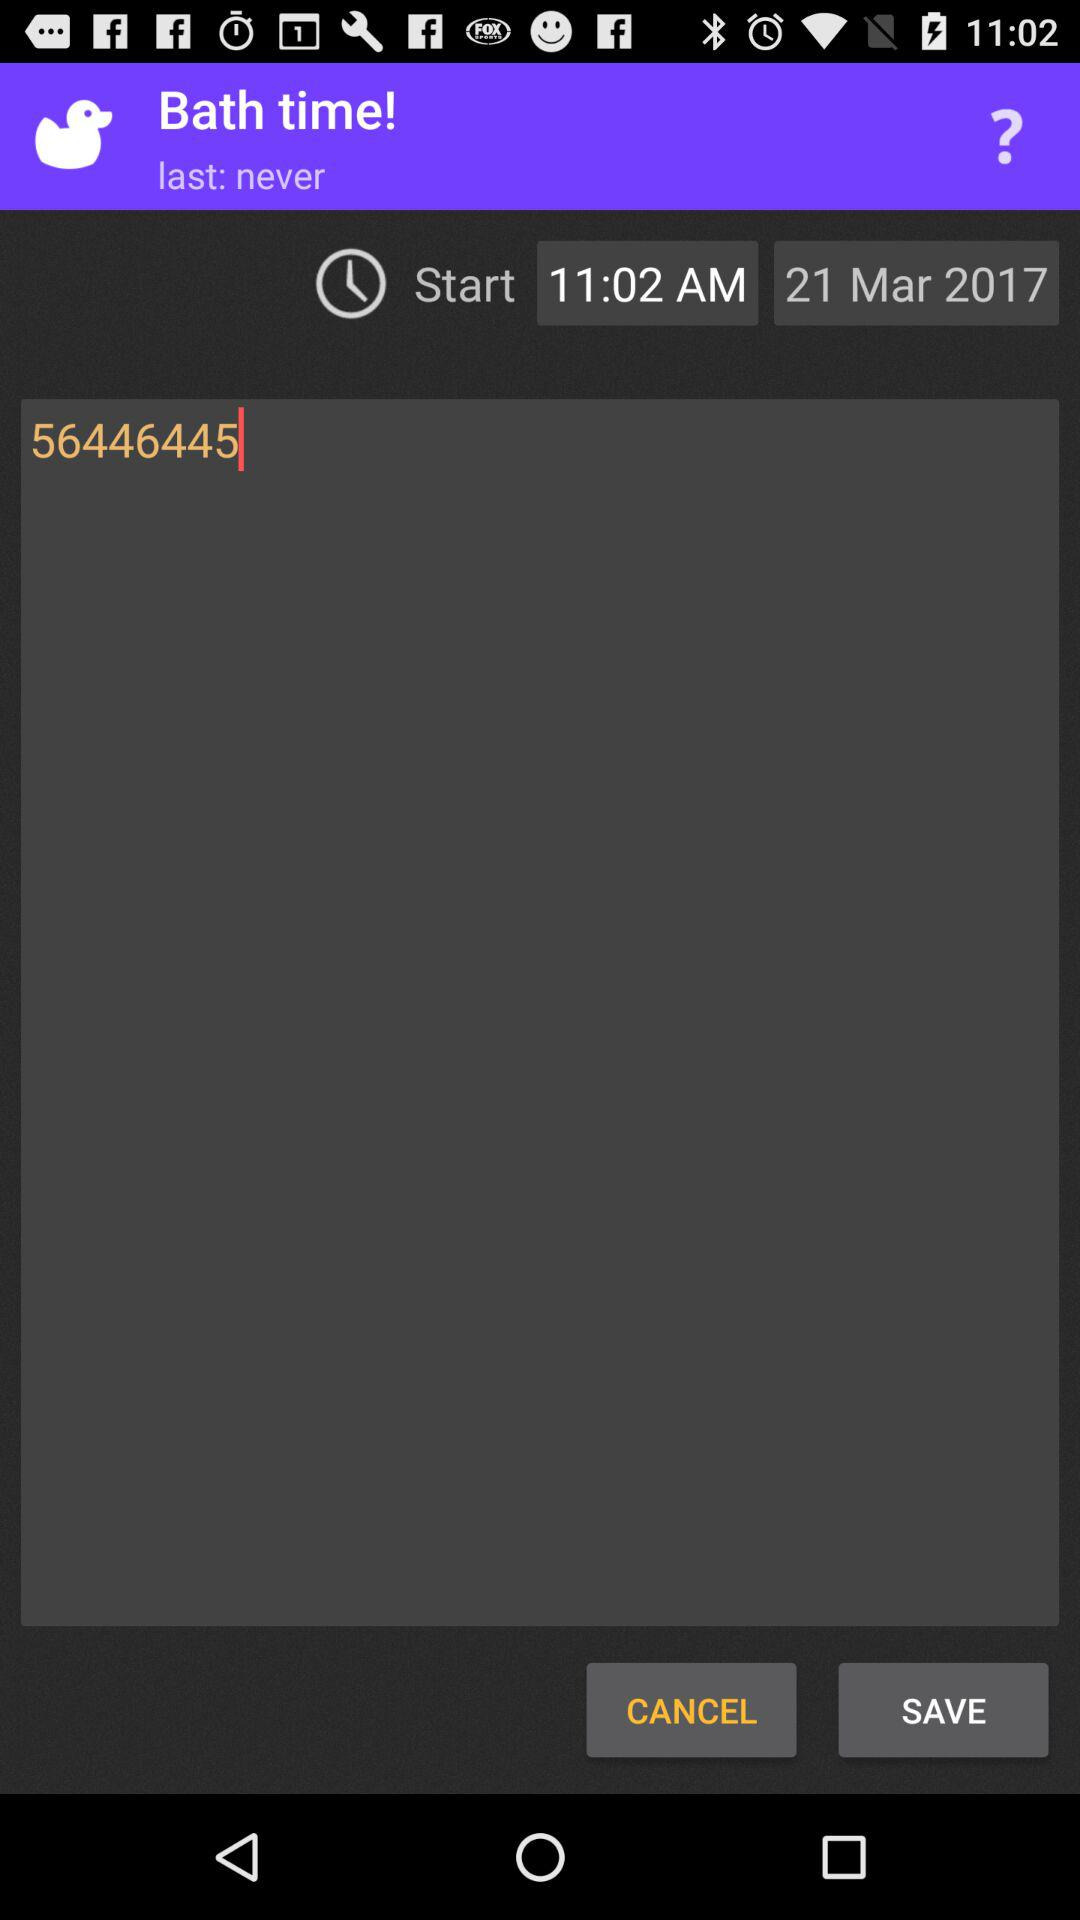What is the selected date? The selected date is March 21, 2017. 